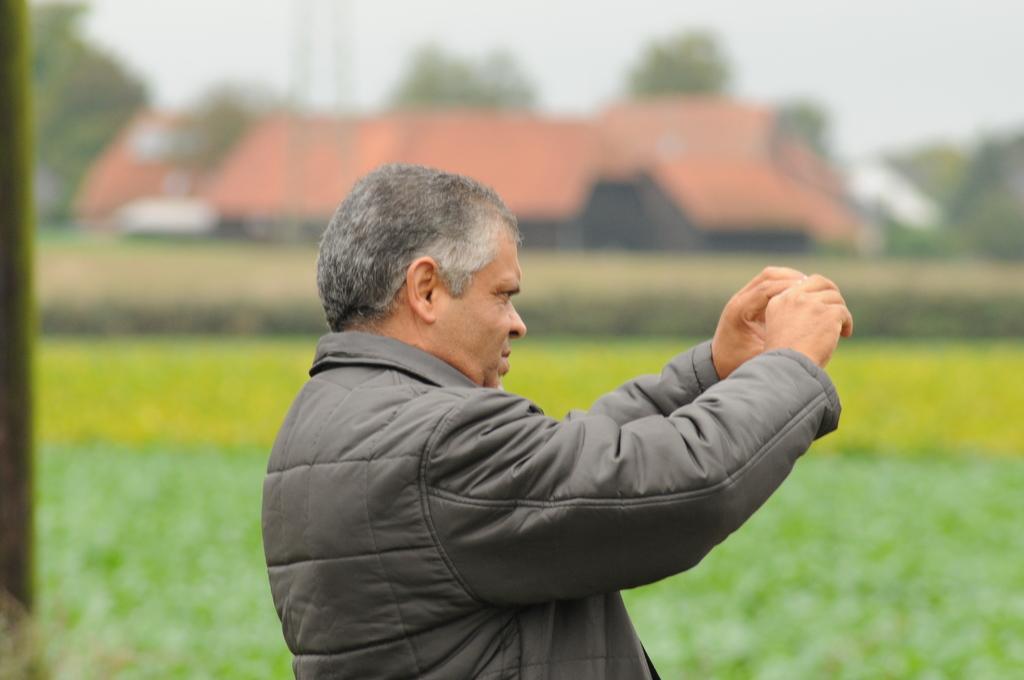In one or two sentences, can you explain what this image depicts? In this image there is the sky towards the top of the image, there are trees, there is a building, there are plants, there is an object towards the left of the image, there is a man standing towards the bottom of the image. 